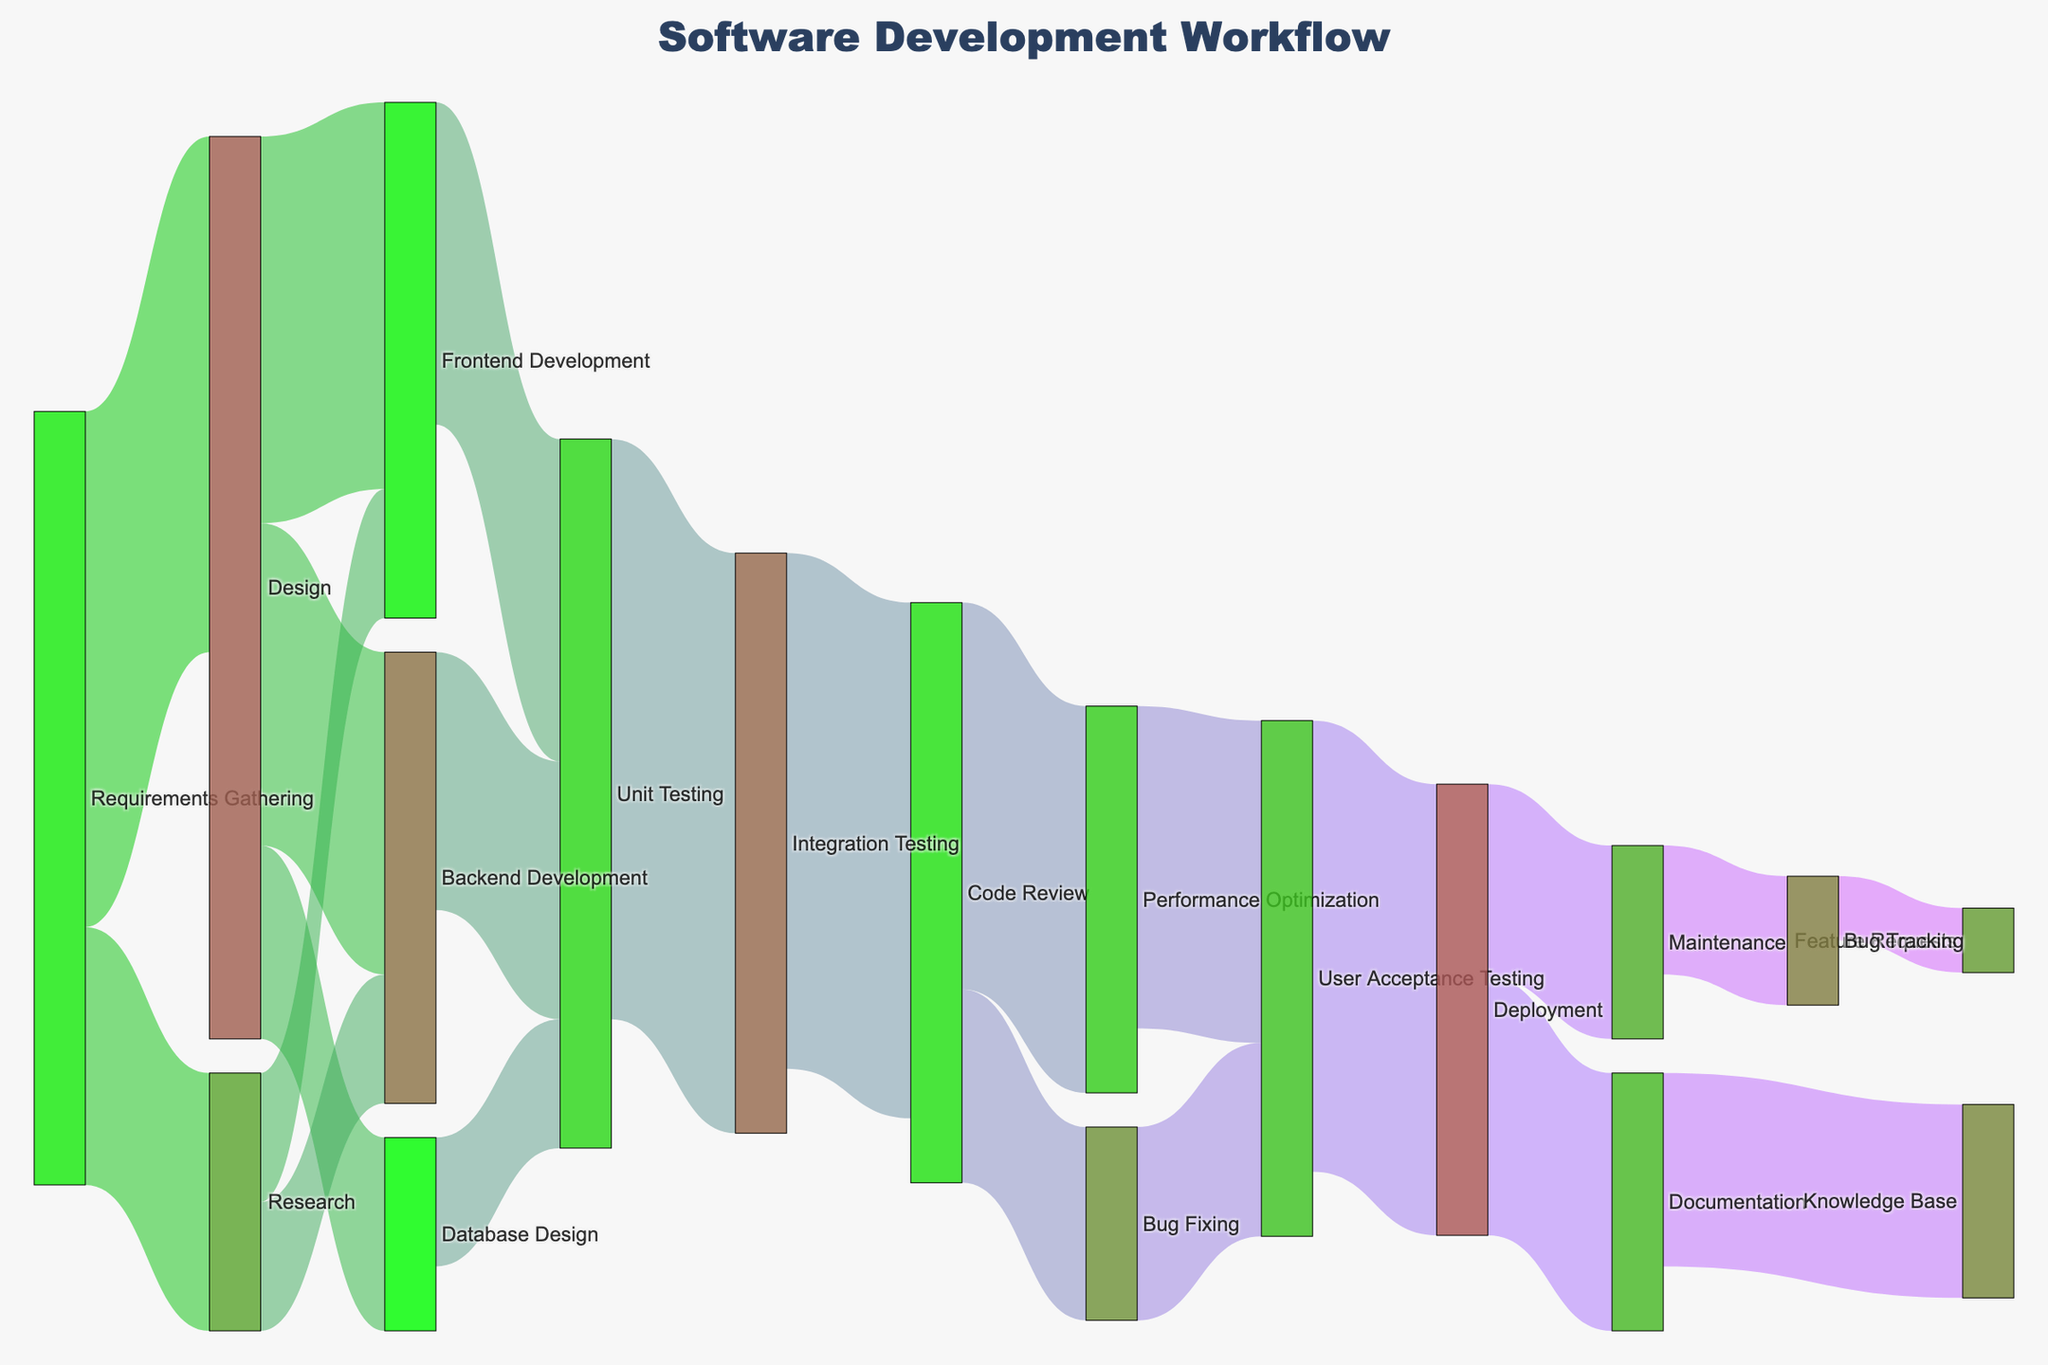What's the title of the Sankey diagram? The title is centered on the top part of the Sankey diagram. It reads "Software Development Workflow."
Answer: Software Development Workflow How many stages are represented in the Sankey diagram? Counting all the unique stages shown in the nodes of the diagram, we find the following: Requirements Gathering, Design, Research, Frontend Development, Backend Development, Database Design, Unit Testing, Integration Testing, Code Review, Performance Optimization, Bug Fixing, User Acceptance Testing, Deployment, Documentation, Maintenance, Knowledge Base, Bug Tracking, Feature Requests. In total, this gives us 18 stages.
Answer: 18 Which stage has the highest number of incoming connections? Count the connections coming into each stage. "User Acceptance Testing" has incoming connections from "Performance Optimization" and "Bug Fixing" with a total of 2 connections, which is the maximum compared to other stages.
Answer: User Acceptance Testing What is the sum of resources allocated from Frontend Development? Looking at the outgoing connections from Frontend Development: Frontend Development to Unit Testing has a value of 25. Summing these values together gives 25.
Answer: 25 Which stage allocates the most resources to Unit Testing? From the nodes that connect to Unit Testing: Frontend Development (25), Backend Development (20), and Database Design (10). The stage allocating the most resources is Frontend Development with 25.
Answer: Frontend Development What is the total resource allocation from Research to Backend Development? The connection from Research to Backend Development has a value of 10, as shown in the diagram.
Answer: 10 Compare the resource allocations from Design to Frontend Development and Backend Development. Which one is greater and by how much? From Design to Frontend Development is 30, and from Design to Backend Development is 25. The difference is 30 - 25 = 5. So, Frontend Development has 5 more resources.
Answer: 5 How many resources flow out from Deployment in total? Deployment has outgoing connections to Documentation (20) and Maintenance (15). Summing these, we get 20 + 15 = 35.
Answer: 35 Which stages are directly connected to Integration Testing? Looking at the connections going into and out of Integration Testing, we see that Unit Testing connects to Integration Testing and Integration Testing connects to Code Review.
Answer: Unit Testing, Code Review 